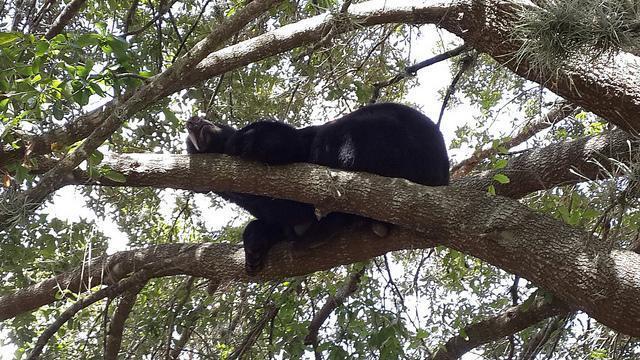How many people are seated?
Give a very brief answer. 0. 